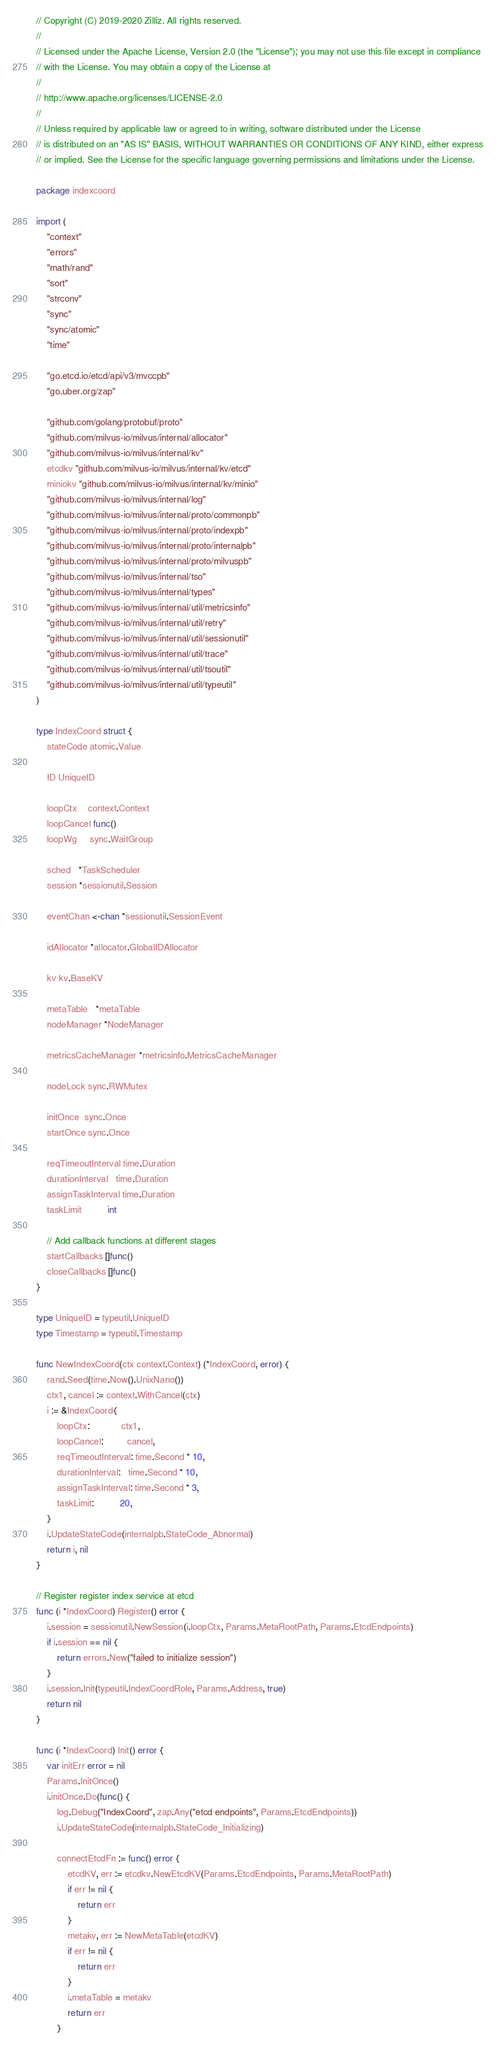<code> <loc_0><loc_0><loc_500><loc_500><_Go_>// Copyright (C) 2019-2020 Zilliz. All rights reserved.
//
// Licensed under the Apache License, Version 2.0 (the "License"); you may not use this file except in compliance
// with the License. You may obtain a copy of the License at
//
// http://www.apache.org/licenses/LICENSE-2.0
//
// Unless required by applicable law or agreed to in writing, software distributed under the License
// is distributed on an "AS IS" BASIS, WITHOUT WARRANTIES OR CONDITIONS OF ANY KIND, either express
// or implied. See the License for the specific language governing permissions and limitations under the License.

package indexcoord

import (
	"context"
	"errors"
	"math/rand"
	"sort"
	"strconv"
	"sync"
	"sync/atomic"
	"time"

	"go.etcd.io/etcd/api/v3/mvccpb"
	"go.uber.org/zap"

	"github.com/golang/protobuf/proto"
	"github.com/milvus-io/milvus/internal/allocator"
	"github.com/milvus-io/milvus/internal/kv"
	etcdkv "github.com/milvus-io/milvus/internal/kv/etcd"
	miniokv "github.com/milvus-io/milvus/internal/kv/minio"
	"github.com/milvus-io/milvus/internal/log"
	"github.com/milvus-io/milvus/internal/proto/commonpb"
	"github.com/milvus-io/milvus/internal/proto/indexpb"
	"github.com/milvus-io/milvus/internal/proto/internalpb"
	"github.com/milvus-io/milvus/internal/proto/milvuspb"
	"github.com/milvus-io/milvus/internal/tso"
	"github.com/milvus-io/milvus/internal/types"
	"github.com/milvus-io/milvus/internal/util/metricsinfo"
	"github.com/milvus-io/milvus/internal/util/retry"
	"github.com/milvus-io/milvus/internal/util/sessionutil"
	"github.com/milvus-io/milvus/internal/util/trace"
	"github.com/milvus-io/milvus/internal/util/tsoutil"
	"github.com/milvus-io/milvus/internal/util/typeutil"
)

type IndexCoord struct {
	stateCode atomic.Value

	ID UniqueID

	loopCtx    context.Context
	loopCancel func()
	loopWg     sync.WaitGroup

	sched   *TaskScheduler
	session *sessionutil.Session

	eventChan <-chan *sessionutil.SessionEvent

	idAllocator *allocator.GlobalIDAllocator

	kv kv.BaseKV

	metaTable   *metaTable
	nodeManager *NodeManager

	metricsCacheManager *metricsinfo.MetricsCacheManager

	nodeLock sync.RWMutex

	initOnce  sync.Once
	startOnce sync.Once

	reqTimeoutInterval time.Duration
	durationInterval   time.Duration
	assignTaskInterval time.Duration
	taskLimit          int

	// Add callback functions at different stages
	startCallbacks []func()
	closeCallbacks []func()
}

type UniqueID = typeutil.UniqueID
type Timestamp = typeutil.Timestamp

func NewIndexCoord(ctx context.Context) (*IndexCoord, error) {
	rand.Seed(time.Now().UnixNano())
	ctx1, cancel := context.WithCancel(ctx)
	i := &IndexCoord{
		loopCtx:            ctx1,
		loopCancel:         cancel,
		reqTimeoutInterval: time.Second * 10,
		durationInterval:   time.Second * 10,
		assignTaskInterval: time.Second * 3,
		taskLimit:          20,
	}
	i.UpdateStateCode(internalpb.StateCode_Abnormal)
	return i, nil
}

// Register register index service at etcd
func (i *IndexCoord) Register() error {
	i.session = sessionutil.NewSession(i.loopCtx, Params.MetaRootPath, Params.EtcdEndpoints)
	if i.session == nil {
		return errors.New("failed to initialize session")
	}
	i.session.Init(typeutil.IndexCoordRole, Params.Address, true)
	return nil
}

func (i *IndexCoord) Init() error {
	var initErr error = nil
	Params.InitOnce()
	i.initOnce.Do(func() {
		log.Debug("IndexCoord", zap.Any("etcd endpoints", Params.EtcdEndpoints))
		i.UpdateStateCode(internalpb.StateCode_Initializing)

		connectEtcdFn := func() error {
			etcdKV, err := etcdkv.NewEtcdKV(Params.EtcdEndpoints, Params.MetaRootPath)
			if err != nil {
				return err
			}
			metakv, err := NewMetaTable(etcdKV)
			if err != nil {
				return err
			}
			i.metaTable = metakv
			return err
		}</code> 